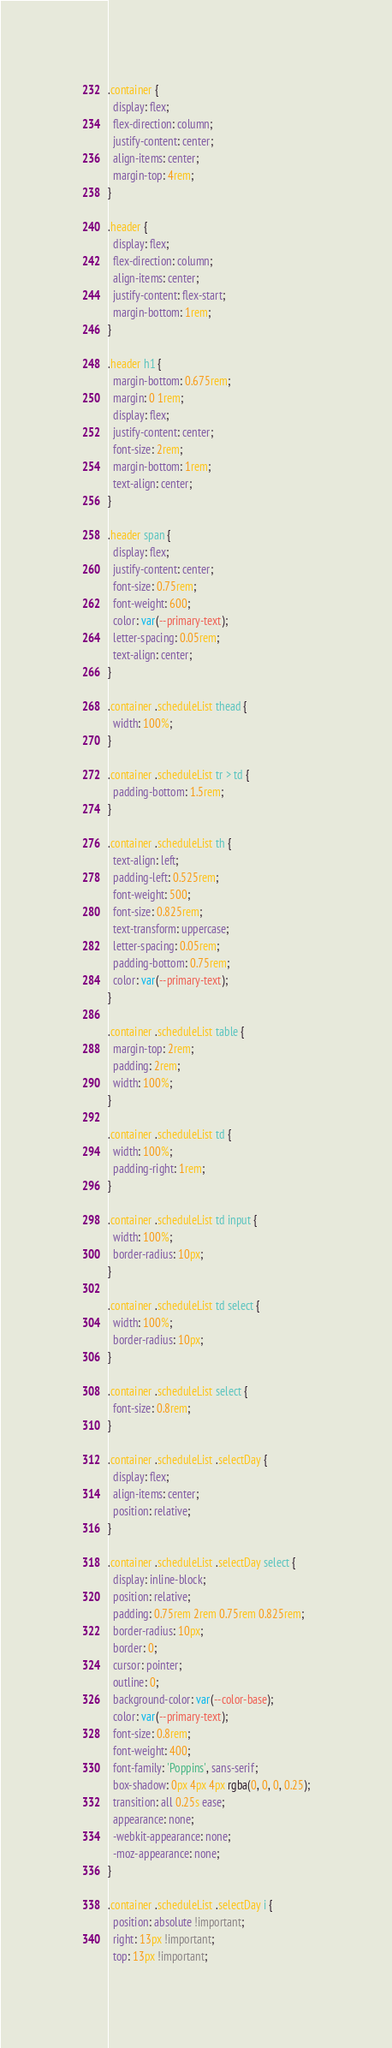Convert code to text. <code><loc_0><loc_0><loc_500><loc_500><_CSS_>.container {
  display: flex;
  flex-direction: column;
  justify-content: center;
  align-items: center;
  margin-top: 4rem;
}

.header {
  display: flex;
  flex-direction: column;
  align-items: center;
  justify-content: flex-start;
  margin-bottom: 1rem;
}

.header h1 {
  margin-bottom: 0.675rem;
  margin: 0 1rem;
  display: flex;
  justify-content: center;
  font-size: 2rem;
  margin-bottom: 1rem;
  text-align: center;
}

.header span {
  display: flex;
  justify-content: center;
  font-size: 0.75rem;
  font-weight: 600;
  color: var(--primary-text);
  letter-spacing: 0.05rem;
  text-align: center;
}

.container .scheduleList thead {
  width: 100%;
}

.container .scheduleList tr > td {
  padding-bottom: 1.5rem;
}

.container .scheduleList th {
  text-align: left;
  padding-left: 0.525rem;
  font-weight: 500;
  font-size: 0.825rem;
  text-transform: uppercase;
  letter-spacing: 0.05rem;
  padding-bottom: 0.75rem;
  color: var(--primary-text);
}

.container .scheduleList table {
  margin-top: 2rem;
  padding: 2rem;
  width: 100%;
}

.container .scheduleList td {
  width: 100%;
  padding-right: 1rem;
}

.container .scheduleList td input {
  width: 100%;
  border-radius: 10px;
}

.container .scheduleList td select {
  width: 100%;
  border-radius: 10px;
}

.container .scheduleList select {
  font-size: 0.8rem;
}

.container .scheduleList .selectDay {
  display: flex;
  align-items: center;
  position: relative;
}

.container .scheduleList .selectDay select {
  display: inline-block;
  position: relative;
  padding: 0.75rem 2rem 0.75rem 0.825rem;
  border-radius: 10px;
  border: 0;
  cursor: pointer;
  outline: 0;
  background-color: var(--color-base);
  color: var(--primary-text);
  font-size: 0.8rem;
  font-weight: 400;
  font-family: 'Poppins', sans-serif;
  box-shadow: 0px 4px 4px rgba(0, 0, 0, 0.25);
  transition: all 0.25s ease;
  appearance: none;
  -webkit-appearance: none;
  -moz-appearance: none;
}

.container .scheduleList .selectDay i {
  position: absolute !important;
  right: 13px !important;
  top: 13px !important;</code> 